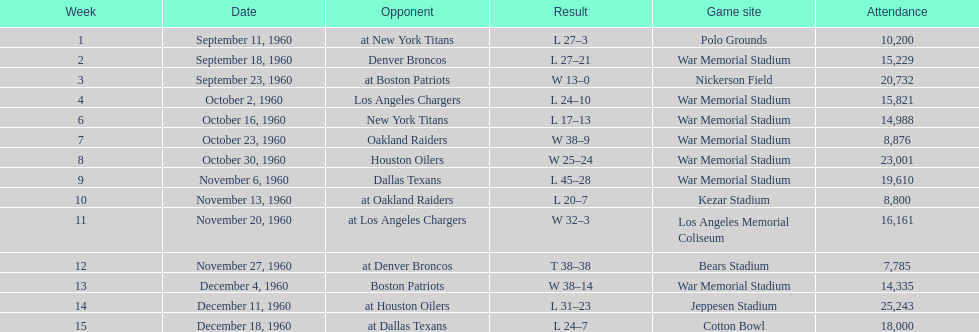Who did the bills face following the oakland raiders? Houston Oilers. 